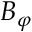Convert formula to latex. <formula><loc_0><loc_0><loc_500><loc_500>B _ { \varphi }</formula> 